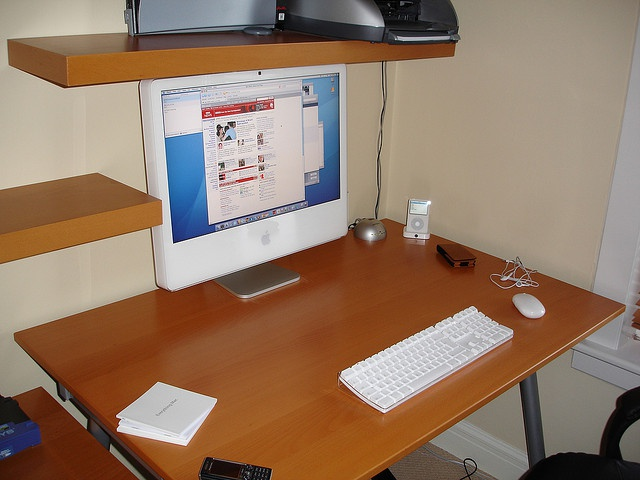Describe the objects in this image and their specific colors. I can see tv in gray, lightgray, darkgray, and blue tones, keyboard in gray, lightgray, and darkgray tones, chair in gray, black, and darkgreen tones, book in gray, lightgray, and darkgray tones, and book in gray, navy, black, and maroon tones in this image. 